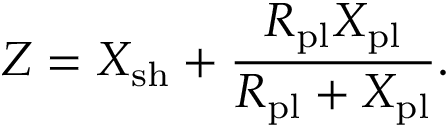<formula> <loc_0><loc_0><loc_500><loc_500>Z = X _ { s h } + \frac { R _ { p l } X _ { p l } } { R _ { p l } + X _ { p l } } .</formula> 